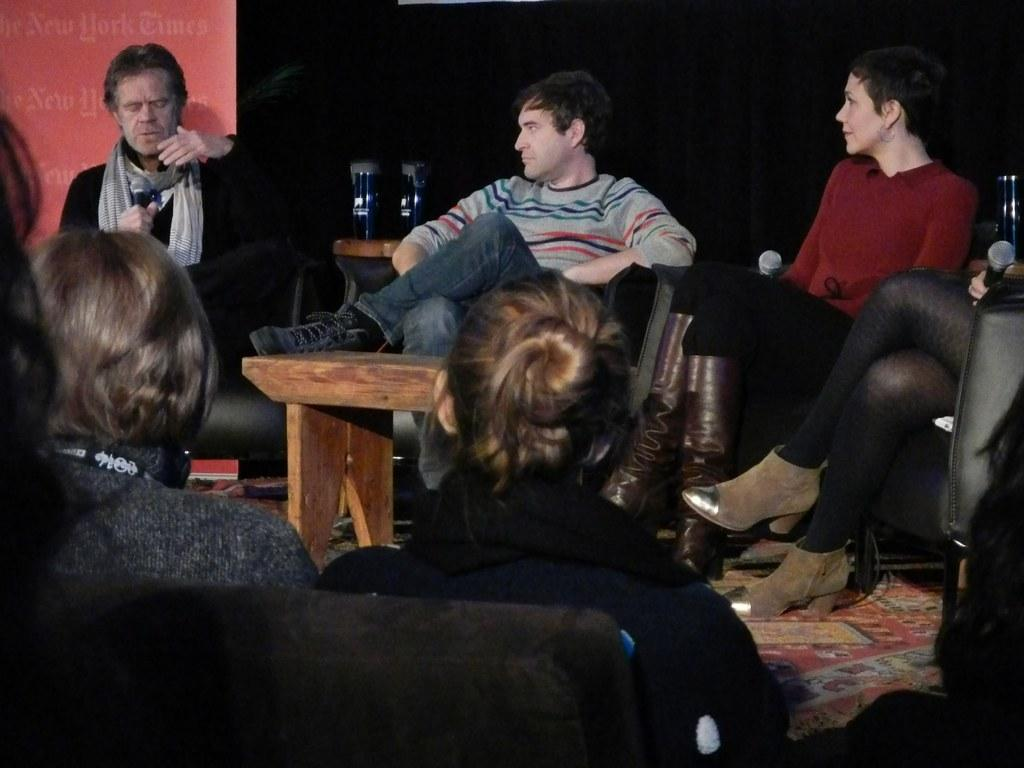How many people are sitting on chairs in the image? There are three people sitting on chairs in the image. What is the person on the left side holding? The person on the left side is holding a microphone. What is the person on the left side doing? The person on the left side is speaking. Are there any other people sitting on chairs in the image? Yes, there are additional people sitting on chairs in front of the first three people. What type of flowers can be seen growing in the person's mouth in the image? There are no flowers visible in the image, and no one is shown with flowers in their mouth. 